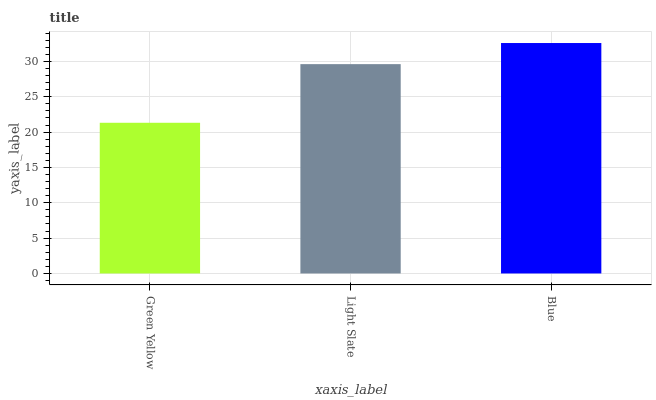Is Green Yellow the minimum?
Answer yes or no. Yes. Is Blue the maximum?
Answer yes or no. Yes. Is Light Slate the minimum?
Answer yes or no. No. Is Light Slate the maximum?
Answer yes or no. No. Is Light Slate greater than Green Yellow?
Answer yes or no. Yes. Is Green Yellow less than Light Slate?
Answer yes or no. Yes. Is Green Yellow greater than Light Slate?
Answer yes or no. No. Is Light Slate less than Green Yellow?
Answer yes or no. No. Is Light Slate the high median?
Answer yes or no. Yes. Is Light Slate the low median?
Answer yes or no. Yes. Is Green Yellow the high median?
Answer yes or no. No. Is Blue the low median?
Answer yes or no. No. 